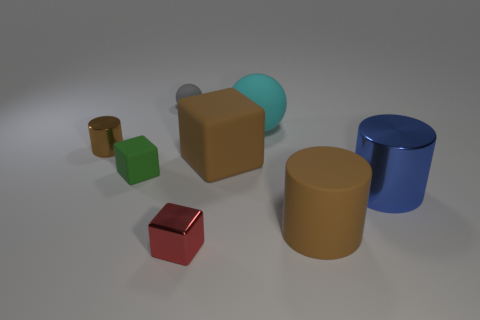Is the cube that is left of the tiny red metal block made of the same material as the cyan ball?
Offer a very short reply. Yes. What number of objects are either brown cylinders or small metallic things in front of the blue metallic thing?
Offer a terse response. 3. What number of tiny red metallic cubes are behind the cylinder that is left of the tiny block that is right of the small gray rubber sphere?
Provide a short and direct response. 0. Do the tiny metallic thing that is in front of the tiny brown thing and the blue metal object have the same shape?
Offer a very short reply. No. There is a tiny shiny thing behind the shiny block; are there any spheres on the right side of it?
Ensure brevity in your answer.  Yes. How many metallic objects are there?
Keep it short and to the point. 3. There is a matte object that is in front of the big brown matte cube and behind the large metallic cylinder; what is its color?
Make the answer very short. Green. There is a blue metal thing that is the same shape as the tiny brown metal object; what size is it?
Your answer should be compact. Large. How many cubes are the same size as the cyan object?
Your answer should be compact. 1. What is the small green thing made of?
Your response must be concise. Rubber. 